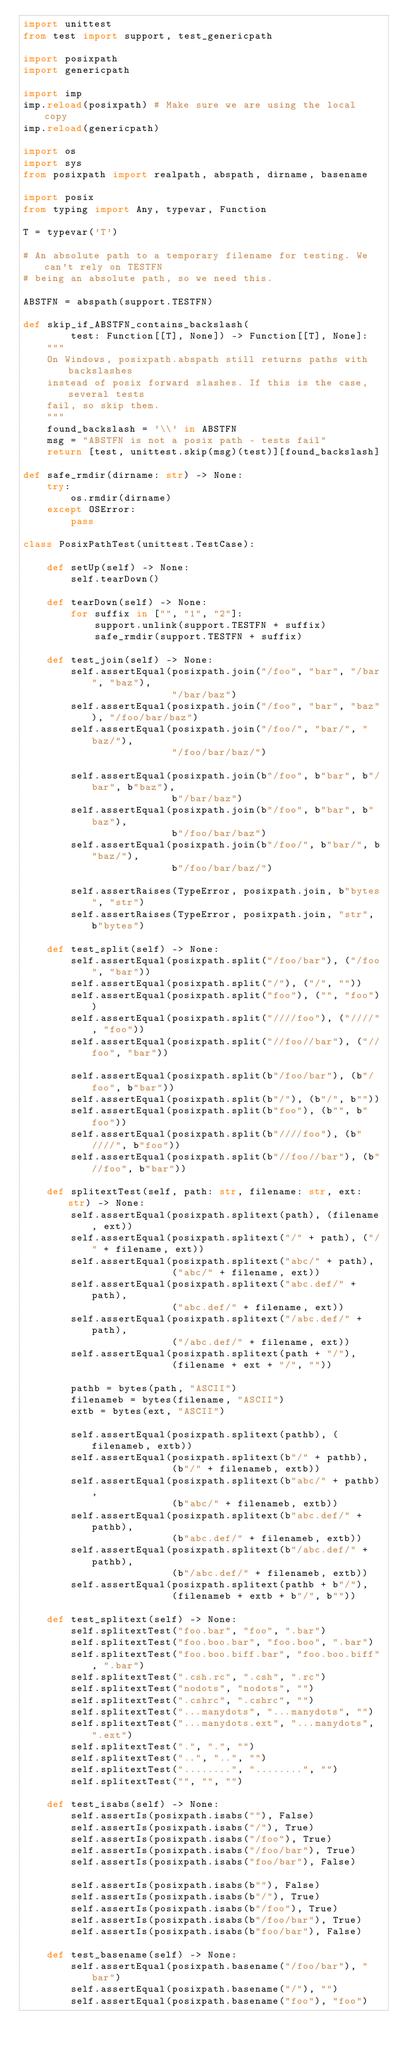<code> <loc_0><loc_0><loc_500><loc_500><_Python_>import unittest
from test import support, test_genericpath

import posixpath
import genericpath

import imp
imp.reload(posixpath) # Make sure we are using the local copy
imp.reload(genericpath)

import os
import sys
from posixpath import realpath, abspath, dirname, basename

import posix
from typing import Any, typevar, Function

T = typevar('T')

# An absolute path to a temporary filename for testing. We can't rely on TESTFN
# being an absolute path, so we need this.

ABSTFN = abspath(support.TESTFN)

def skip_if_ABSTFN_contains_backslash(
        test: Function[[T], None]) -> Function[[T], None]:
    """
    On Windows, posixpath.abspath still returns paths with backslashes
    instead of posix forward slashes. If this is the case, several tests
    fail, so skip them.
    """
    found_backslash = '\\' in ABSTFN
    msg = "ABSTFN is not a posix path - tests fail"
    return [test, unittest.skip(msg)(test)][found_backslash]

def safe_rmdir(dirname: str) -> None:
    try:
        os.rmdir(dirname)
    except OSError:
        pass

class PosixPathTest(unittest.TestCase):

    def setUp(self) -> None:
        self.tearDown()

    def tearDown(self) -> None:
        for suffix in ["", "1", "2"]:
            support.unlink(support.TESTFN + suffix)
            safe_rmdir(support.TESTFN + suffix)

    def test_join(self) -> None:
        self.assertEqual(posixpath.join("/foo", "bar", "/bar", "baz"),
                         "/bar/baz")
        self.assertEqual(posixpath.join("/foo", "bar", "baz"), "/foo/bar/baz")
        self.assertEqual(posixpath.join("/foo/", "bar/", "baz/"),
                         "/foo/bar/baz/")

        self.assertEqual(posixpath.join(b"/foo", b"bar", b"/bar", b"baz"),
                         b"/bar/baz")
        self.assertEqual(posixpath.join(b"/foo", b"bar", b"baz"),
                         b"/foo/bar/baz")
        self.assertEqual(posixpath.join(b"/foo/", b"bar/", b"baz/"),
                         b"/foo/bar/baz/")

        self.assertRaises(TypeError, posixpath.join, b"bytes", "str")
        self.assertRaises(TypeError, posixpath.join, "str", b"bytes")

    def test_split(self) -> None:
        self.assertEqual(posixpath.split("/foo/bar"), ("/foo", "bar"))
        self.assertEqual(posixpath.split("/"), ("/", ""))
        self.assertEqual(posixpath.split("foo"), ("", "foo"))
        self.assertEqual(posixpath.split("////foo"), ("////", "foo"))
        self.assertEqual(posixpath.split("//foo//bar"), ("//foo", "bar"))

        self.assertEqual(posixpath.split(b"/foo/bar"), (b"/foo", b"bar"))
        self.assertEqual(posixpath.split(b"/"), (b"/", b""))
        self.assertEqual(posixpath.split(b"foo"), (b"", b"foo"))
        self.assertEqual(posixpath.split(b"////foo"), (b"////", b"foo"))
        self.assertEqual(posixpath.split(b"//foo//bar"), (b"//foo", b"bar"))

    def splitextTest(self, path: str, filename: str, ext: str) -> None:
        self.assertEqual(posixpath.splitext(path), (filename, ext))
        self.assertEqual(posixpath.splitext("/" + path), ("/" + filename, ext))
        self.assertEqual(posixpath.splitext("abc/" + path),
                         ("abc/" + filename, ext))
        self.assertEqual(posixpath.splitext("abc.def/" + path),
                         ("abc.def/" + filename, ext))
        self.assertEqual(posixpath.splitext("/abc.def/" + path),
                         ("/abc.def/" + filename, ext))
        self.assertEqual(posixpath.splitext(path + "/"),
                         (filename + ext + "/", ""))

        pathb = bytes(path, "ASCII")
        filenameb = bytes(filename, "ASCII")
        extb = bytes(ext, "ASCII")

        self.assertEqual(posixpath.splitext(pathb), (filenameb, extb))
        self.assertEqual(posixpath.splitext(b"/" + pathb),
                         (b"/" + filenameb, extb))
        self.assertEqual(posixpath.splitext(b"abc/" + pathb),
                         (b"abc/" + filenameb, extb))
        self.assertEqual(posixpath.splitext(b"abc.def/" + pathb),
                         (b"abc.def/" + filenameb, extb))
        self.assertEqual(posixpath.splitext(b"/abc.def/" + pathb),
                         (b"/abc.def/" + filenameb, extb))
        self.assertEqual(posixpath.splitext(pathb + b"/"),
                         (filenameb + extb + b"/", b""))

    def test_splitext(self) -> None:
        self.splitextTest("foo.bar", "foo", ".bar")
        self.splitextTest("foo.boo.bar", "foo.boo", ".bar")
        self.splitextTest("foo.boo.biff.bar", "foo.boo.biff", ".bar")
        self.splitextTest(".csh.rc", ".csh", ".rc")
        self.splitextTest("nodots", "nodots", "")
        self.splitextTest(".cshrc", ".cshrc", "")
        self.splitextTest("...manydots", "...manydots", "")
        self.splitextTest("...manydots.ext", "...manydots", ".ext")
        self.splitextTest(".", ".", "")
        self.splitextTest("..", "..", "")
        self.splitextTest("........", "........", "")
        self.splitextTest("", "", "")

    def test_isabs(self) -> None:
        self.assertIs(posixpath.isabs(""), False)
        self.assertIs(posixpath.isabs("/"), True)
        self.assertIs(posixpath.isabs("/foo"), True)
        self.assertIs(posixpath.isabs("/foo/bar"), True)
        self.assertIs(posixpath.isabs("foo/bar"), False)

        self.assertIs(posixpath.isabs(b""), False)
        self.assertIs(posixpath.isabs(b"/"), True)
        self.assertIs(posixpath.isabs(b"/foo"), True)
        self.assertIs(posixpath.isabs(b"/foo/bar"), True)
        self.assertIs(posixpath.isabs(b"foo/bar"), False)

    def test_basename(self) -> None:
        self.assertEqual(posixpath.basename("/foo/bar"), "bar")
        self.assertEqual(posixpath.basename("/"), "")
        self.assertEqual(posixpath.basename("foo"), "foo")</code> 